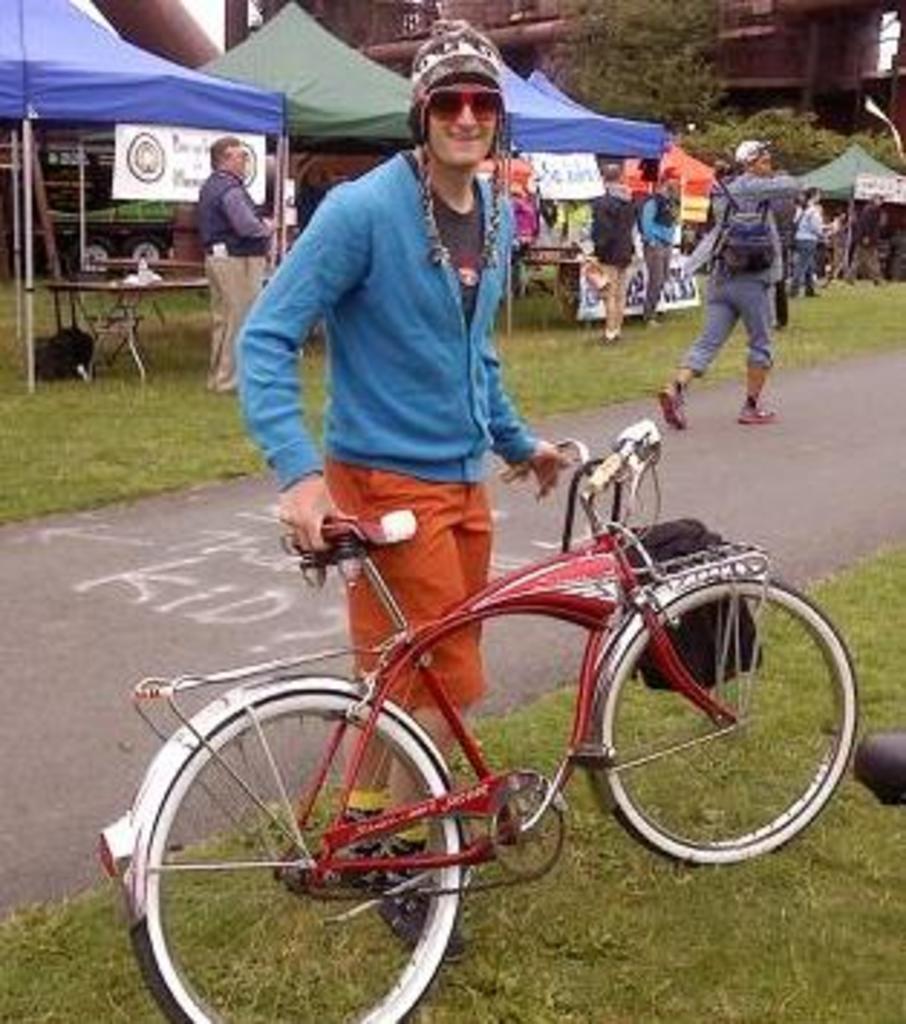Could you give a brief overview of what you see in this image? In the center of the image we can see a man standing and holding a bicycle. In the background there are people, tents, trees and buildings. We can see tables and there is a road. 